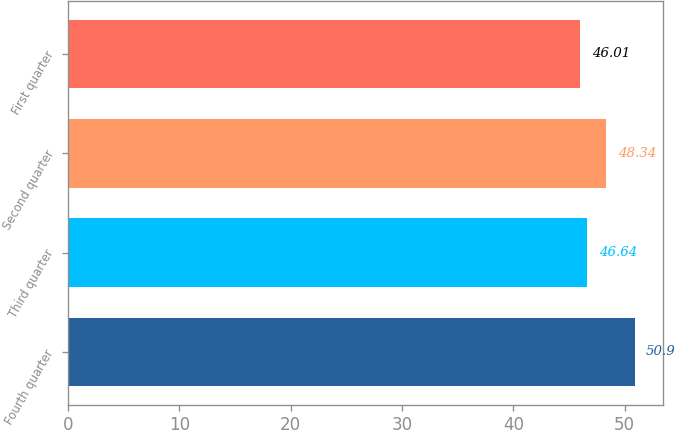Convert chart to OTSL. <chart><loc_0><loc_0><loc_500><loc_500><bar_chart><fcel>Fourth quarter<fcel>Third quarter<fcel>Second quarter<fcel>First quarter<nl><fcel>50.9<fcel>46.64<fcel>48.34<fcel>46.01<nl></chart> 